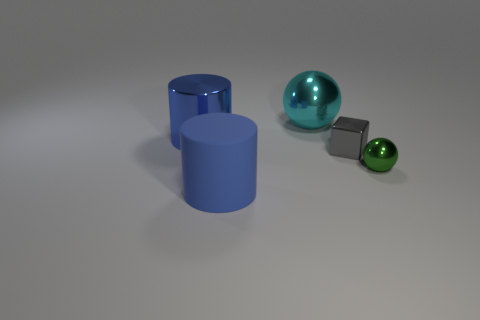What material is the big cylinder that is the same color as the matte thing?
Provide a short and direct response. Metal. How many objects are either purple rubber things or things in front of the big blue shiny object?
Ensure brevity in your answer.  3. What number of other things have the same shape as the gray metallic thing?
Your answer should be compact. 0. There is a sphere that is the same size as the blue metallic cylinder; what is its material?
Provide a succinct answer. Metal. How big is the cylinder that is in front of the gray metallic thing behind the big cylinder that is in front of the gray metallic thing?
Offer a very short reply. Large. Does the big thing that is on the right side of the big rubber cylinder have the same color as the tiny shiny block in front of the cyan shiny thing?
Offer a terse response. No. How many blue objects are either big things or large matte objects?
Your answer should be very brief. 2. What number of shiny cubes have the same size as the rubber cylinder?
Provide a short and direct response. 0. Do the big blue cylinder that is in front of the big metallic cylinder and the small gray thing have the same material?
Keep it short and to the point. No. Is there a cyan metallic thing to the left of the metal ball that is left of the small gray metal cube?
Provide a succinct answer. No. 